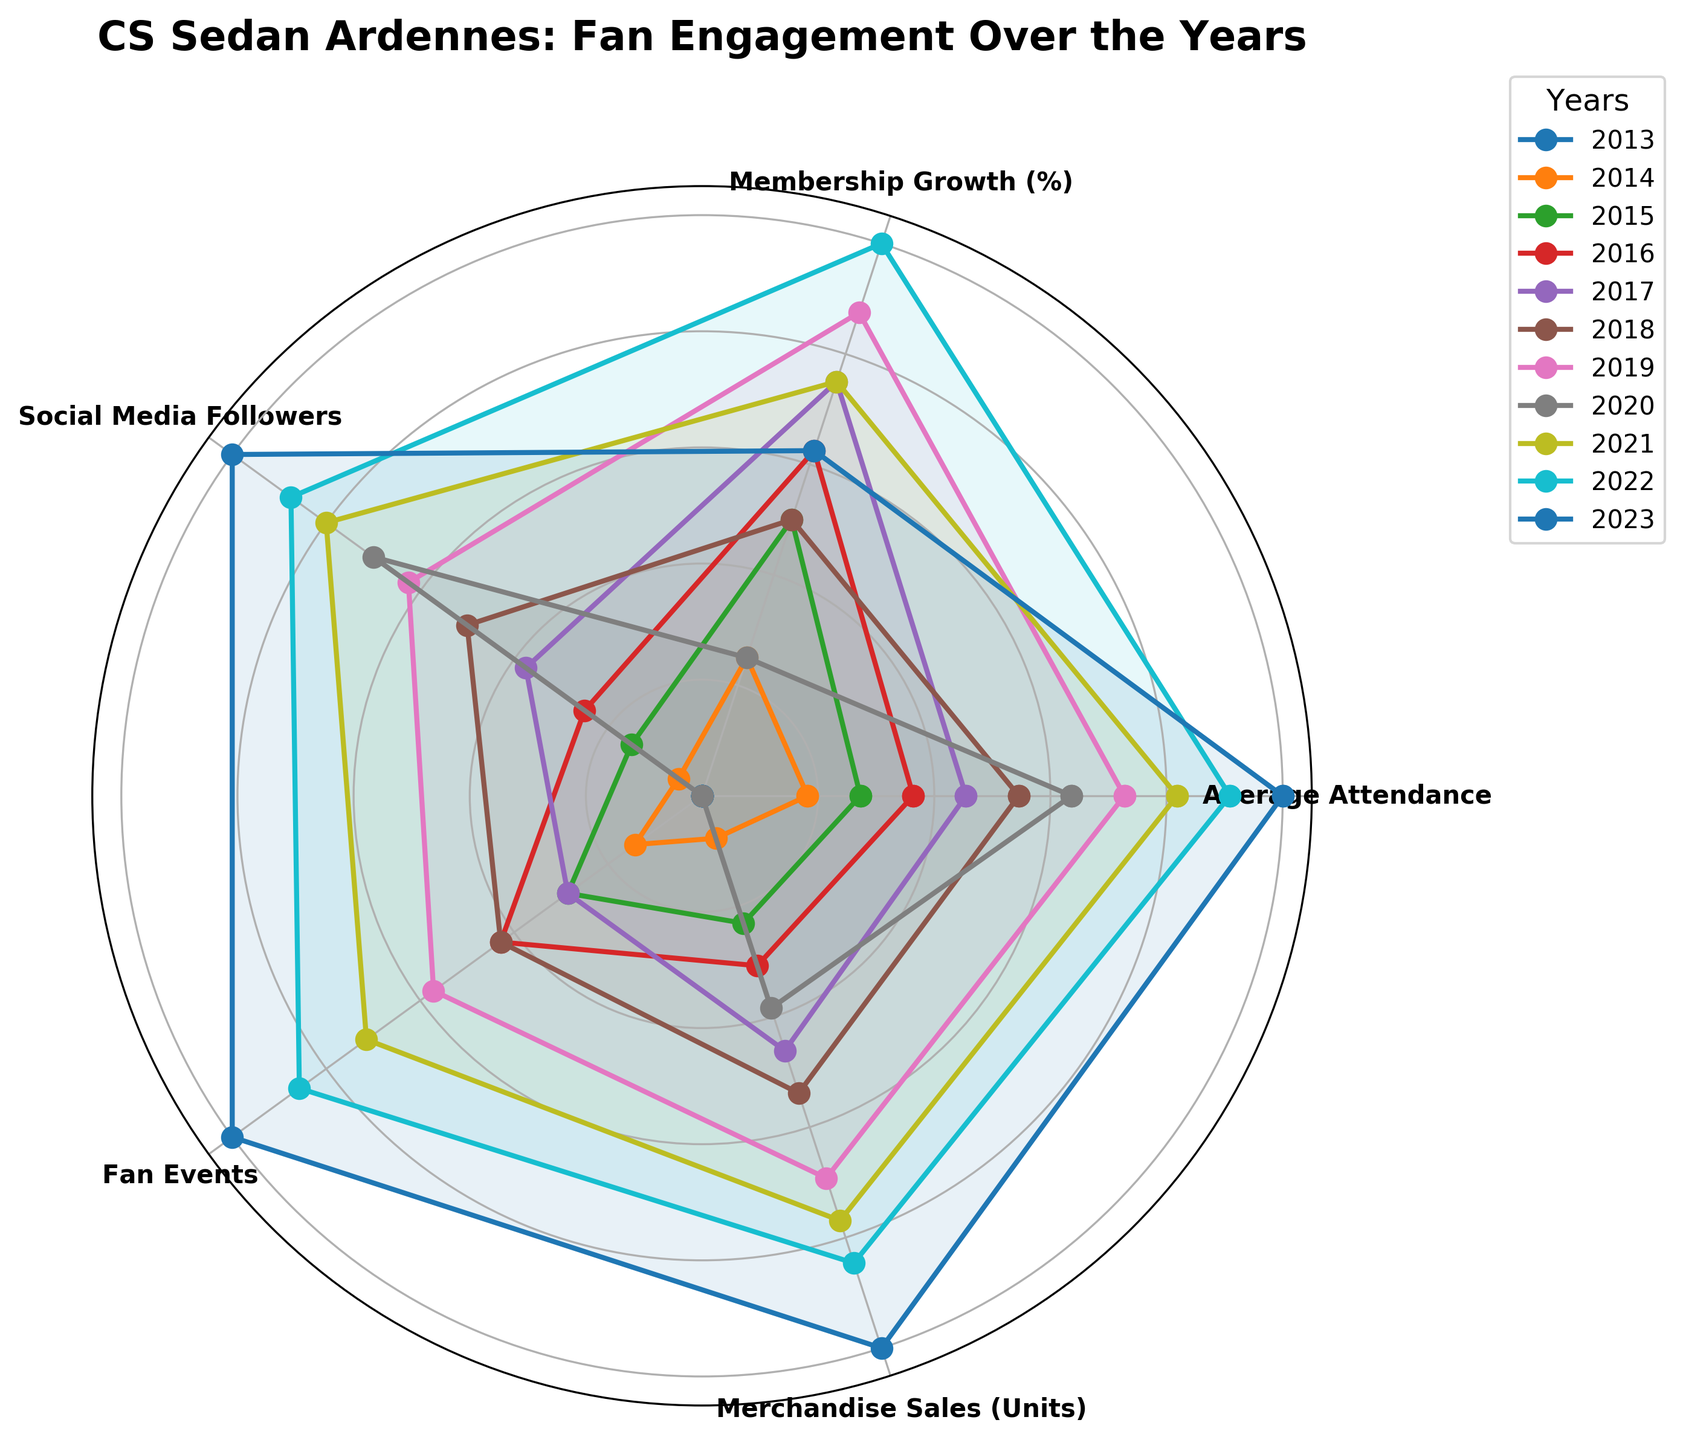What's the title of the radar chart? The title is located at the top of the chart. It summarizes the chart's theme or subject.
Answer: CS Sedan Ardennes: Fan Engagement Over the Years How many categories are represented in the radar chart? The radar chart has labels for each of the categories placed around the perimeter. By counting them, we can determine the number of categories.
Answer: 5 Which year had the highest average attendance? To find the year with the highest average attendance, look at the category labeled "Average Attendance" and find the data point that is furthest from the center.
Answer: 2023 What was the trend in fan events from 2013 to 2023? Track the data points related to "Fan Events" for each year and observe their positions to determine if they are moving towards or away from the center.
Answer: Increasing Which two years had the same level of social media followers? Compare the "Social Media Followers" data points for all years and identify any that are aligned at the same distance from the center.
Answer: 2020 and 2018 Among Membership Growth (%) and Merchandise Sales (Units), which category showed the most improvement from 2013 to 2023? Assess the changes in data points for "Membership Growth (%)" and "Merchandise Sales (Units)" categories by comparing their positions in 2013 and 2023.
Answer: Merchandise Sales What has been the trend in Membership Growth (%) from 2013 to 2023, and which years saw an increase? Examine the variation in data points for "Membership Growth (%)" over the years, and identify those years where the data points moved outward (increased).
Answer: Overall increasing, increase in 2014, 2015, 2016, 2017, 2019, 2021, 2022, 2023 Comparing Average Attendance and Fan Events, which category saw a dip in 2020? Locate the data points for 2020 in "Average Attendance" and "Fan Events", and see if there is a noticeable inward shift toward the center in either category.
Answer: Fan Events How did Merchandise Sales (Units) change from 2019 to 2020? Compare the distance of the data points for "Merchandise Sales (Units)" between 2019 and 2020 to see if the data point moves inward (decreased) or outward (increased).
Answer: Decrease 